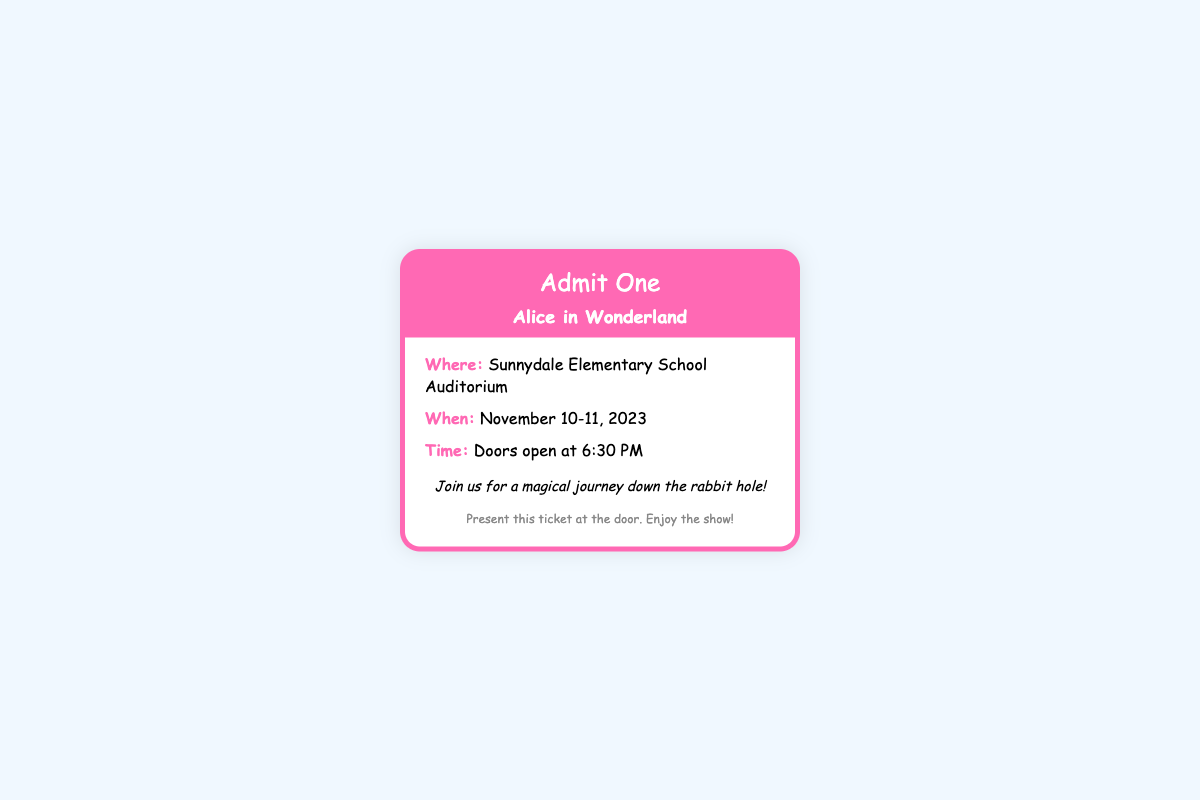What is the title of the play? The title of the play is mentioned prominently in the document as "Alice in Wonderland."
Answer: Alice in Wonderland Where is the event taking place? The location of the event is specified in the document as "Sunnydale Elementary School Auditorium."
Answer: Sunnydale Elementary School Auditorium What are the dates of the performance? The specific dates for the performance are provided, indicating when the event is happening, which are November 10-11, 2023.
Answer: November 10-11, 2023 What time do the doors open? The document states that the doors open at "6:30 PM," which is the time when guests can enter the auditorium.
Answer: 6:30 PM What kind of event is this ticket for? The document specifies that this ticket is for a school play, as indicated by the text "Admit One" and "Alice in Wonderland."
Answer: school play What message is included in the ticket note? The note provides a welcoming message to the audience, detailing their experience at the play, which is "Join us for a magical journey down the rabbit hole!"
Answer: Join us for a magical journey down the rabbit hole! What should be presented at the door? The footer indicates that "Present this ticket at the door" is required for entry to the event.
Answer: this ticket What is the color of the ticket's header? The document describes the color of the ticket's header as "pink," specifically using the color code #ff69b4.
Answer: pink 